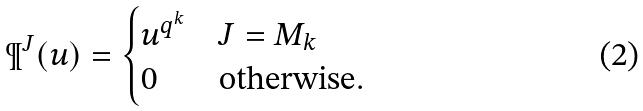<formula> <loc_0><loc_0><loc_500><loc_500>\P ^ { J } ( u ) = \begin{cases} u ^ { q ^ { k } } & J = M _ { k } \\ 0 & \text {otherwise} . \end{cases}</formula> 